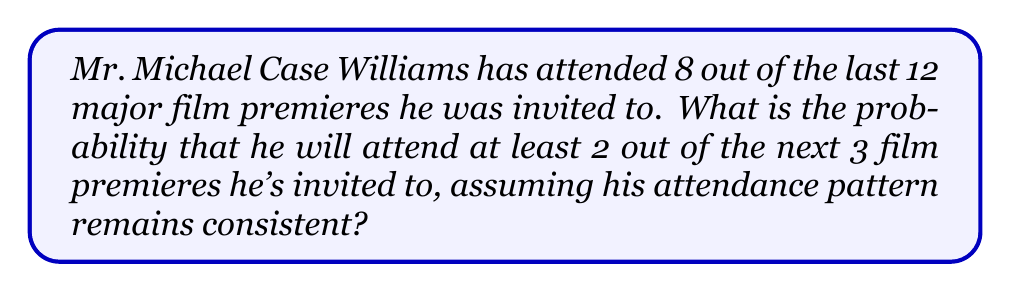What is the answer to this math problem? Let's approach this step-by-step:

1) First, we need to calculate the probability of Mr. Williams attending a single premiere:
   $$P(\text{attend}) = \frac{8}{12} = \frac{2}{3}$$

2) The probability of not attending is:
   $$P(\text{not attend}) = 1 - \frac{2}{3} = \frac{1}{3}$$

3) Now, we need to calculate the probability of attending at least 2 out of 3 premieres. This can happen in two ways:
   a) He attends all 3 premieres
   b) He attends exactly 2 out of 3 premieres

4) The probability of attending all 3 premieres is:
   $$P(\text{all 3}) = (\frac{2}{3})^3 = \frac{8}{27}$$

5) The probability of attending exactly 2 out of 3 premieres can be calculated using the binomial probability formula:
   $$P(\text{exactly 2}) = \binom{3}{2} (\frac{2}{3})^2 (\frac{1}{3})^1 = 3 \cdot \frac{4}{9} \cdot \frac{1}{3} = \frac{4}{9}$$

6) The total probability of attending at least 2 out of 3 premieres is the sum of these probabilities:
   $$P(\text{at least 2}) = P(\text{all 3}) + P(\text{exactly 2}) = \frac{8}{27} + \frac{4}{9} = \frac{8}{27} + \frac{12}{27} = \frac{20}{27}$$

Therefore, the probability that Mr. Williams will attend at least 2 out of the next 3 film premieres is $\frac{20}{27}$ or approximately 0.7407 or 74.07%.
Answer: $\frac{20}{27}$ 